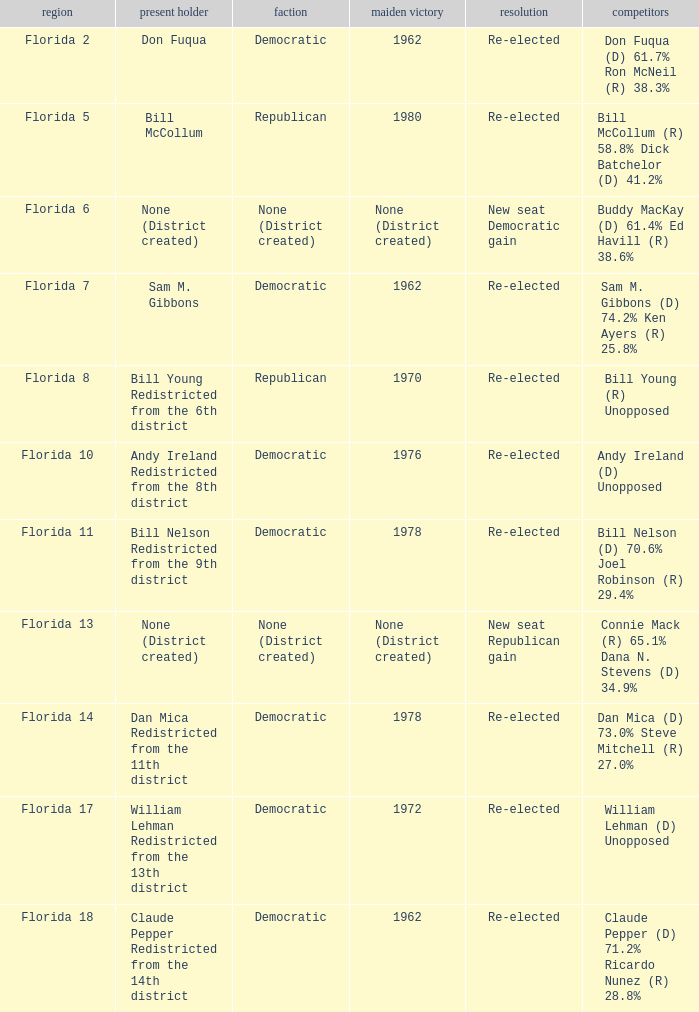What's the first elected with district being florida 7 1962.0. 